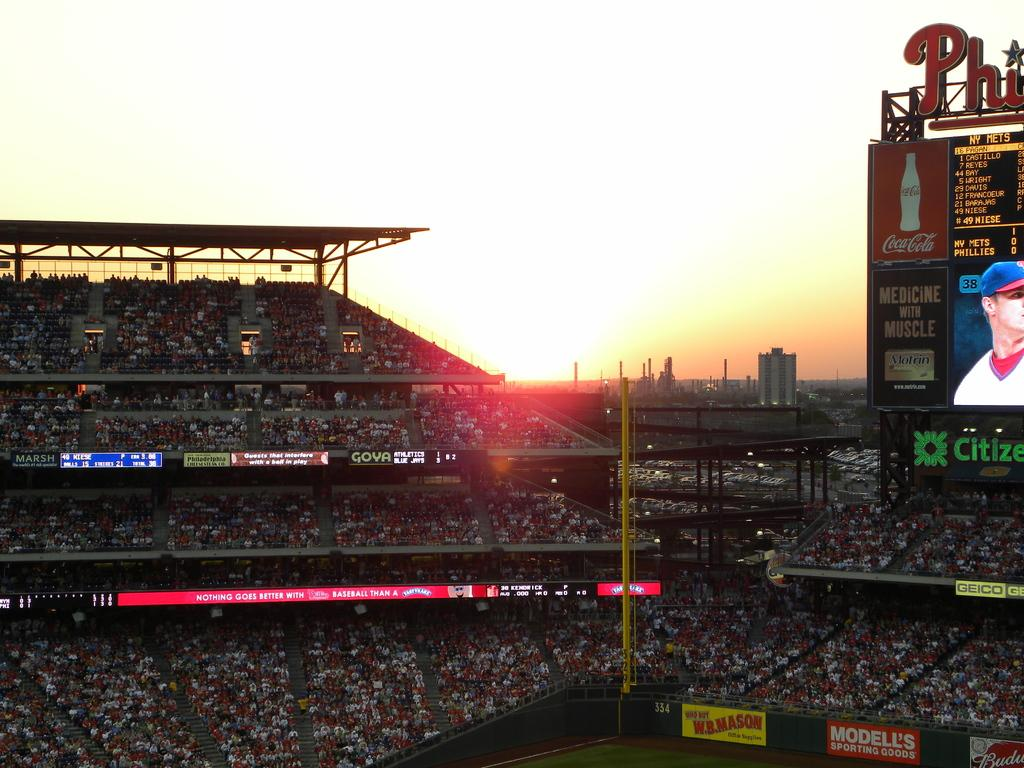What is located on the right side of the image? There is a screen on the right side of the image. What can be seen on the screen? A person is visible on the screen. What is written or displayed on the board in the image? There is text written on a board in the image. What type of environment is visible in the background of the image? There are buildings in the background of the image. Can you tell me how many knees are visible in the image? There are no knees visible in the image; it features a screen with a person and a board with text. What type of industry is depicted in the image? There is no specific industry depicted in the image; it shows a screen, a person, a board with text, and buildings in the background. 